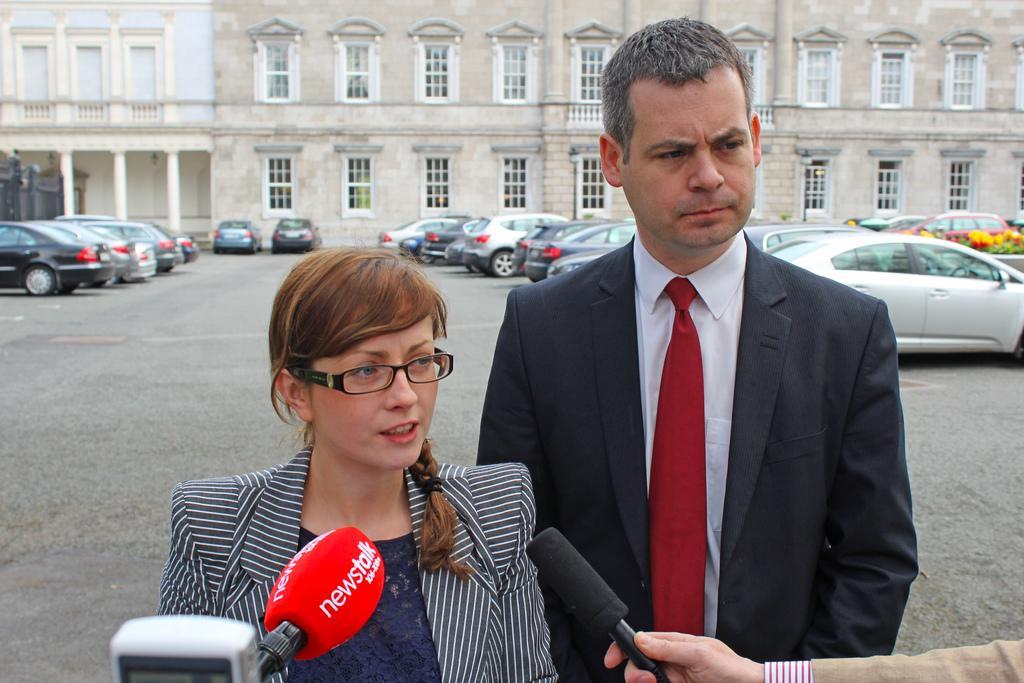Please provide a concise description of this image. In this image it seems like there are two people who are talking in the mic. At background there is a building with the windows and in front of the building there are cars parked. 